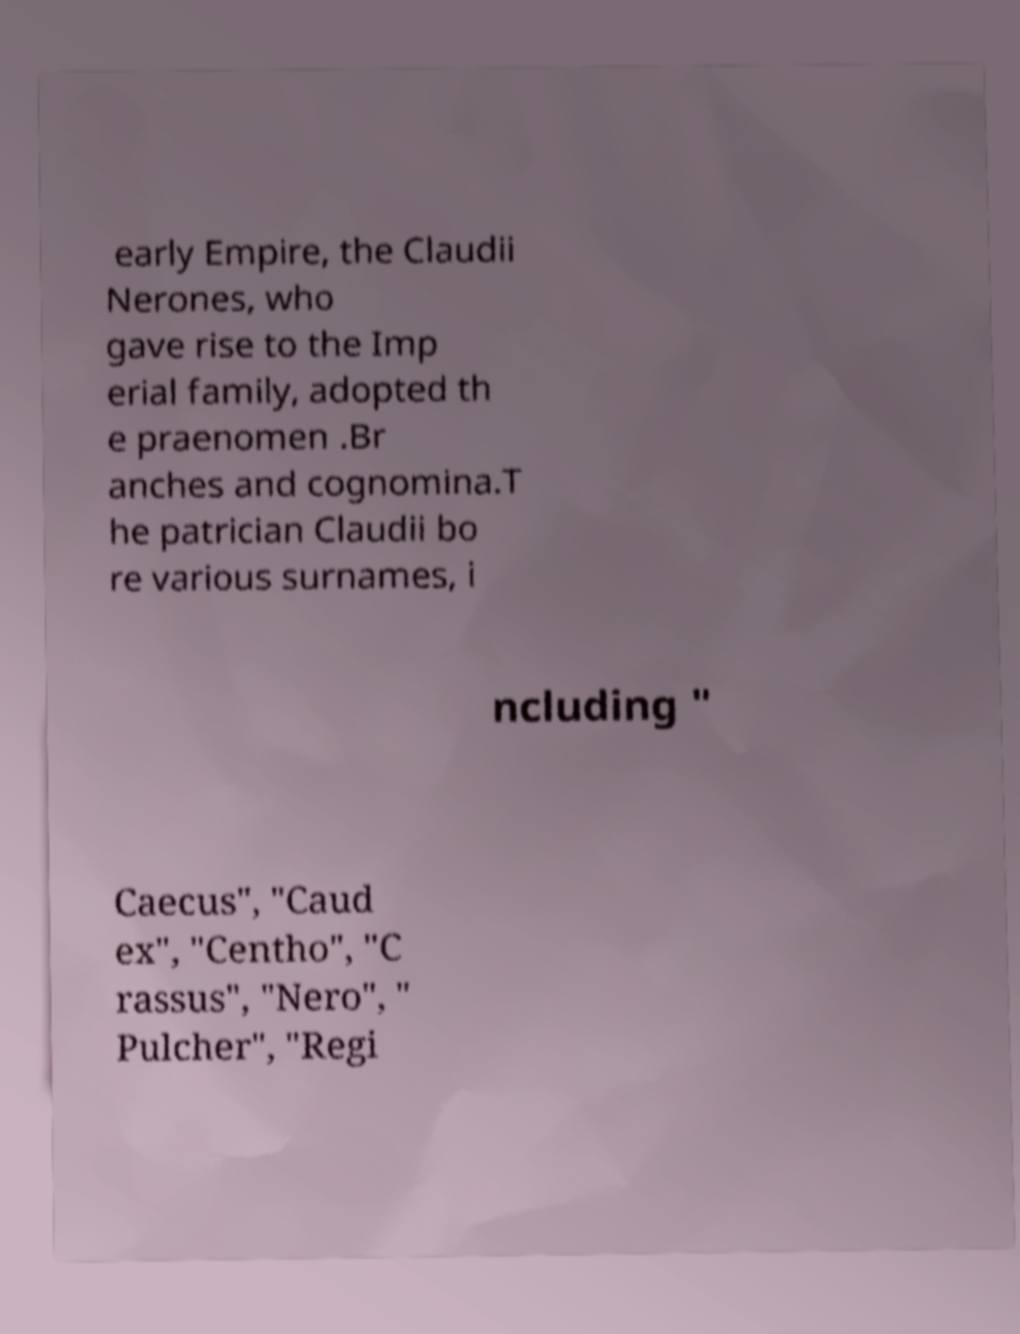There's text embedded in this image that I need extracted. Can you transcribe it verbatim? early Empire, the Claudii Nerones, who gave rise to the Imp erial family, adopted th e praenomen .Br anches and cognomina.T he patrician Claudii bo re various surnames, i ncluding " Caecus", "Caud ex", "Centho", "C rassus", "Nero", " Pulcher", "Regi 